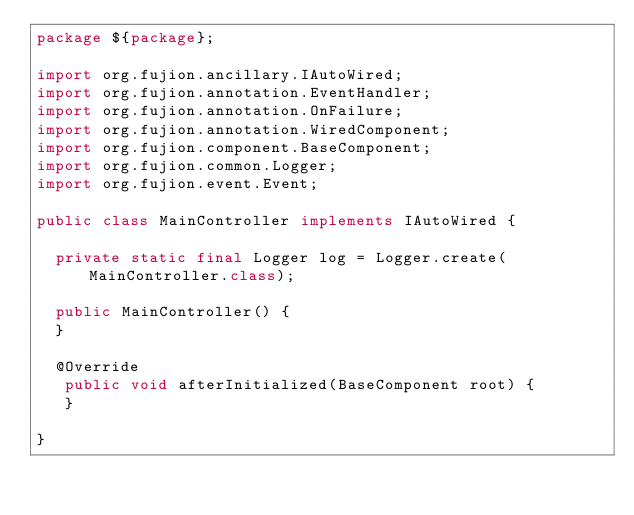Convert code to text. <code><loc_0><loc_0><loc_500><loc_500><_Java_>package ${package};

import org.fujion.ancillary.IAutoWired;
import org.fujion.annotation.EventHandler;
import org.fujion.annotation.OnFailure;
import org.fujion.annotation.WiredComponent;
import org.fujion.component.BaseComponent;
import org.fujion.common.Logger;
import org.fujion.event.Event;

public class MainController implements IAutoWired {

	private static final Logger log = Logger.create(MainController.class);

	public MainController() {
	}
	
	@Override
   public void afterInitialized(BaseComponent root) {
   }

}
</code> 